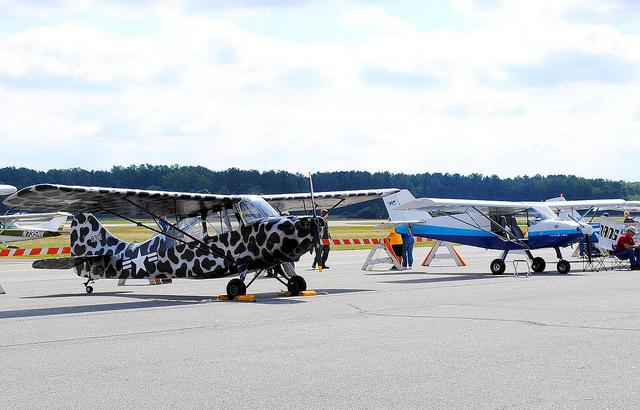What animal mimics the pattern of the plane to the left?

Choices:
A) cheetah
B) snow leopard
C) frog
D) dog snow leopard 